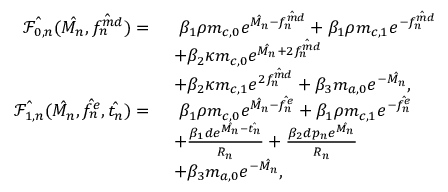<formula> <loc_0><loc_0><loc_500><loc_500>\begin{array} { r l } { \hat { \mathcal { F } _ { 0 , n } } ( \hat { M _ { n } } , \hat { f _ { n } ^ { m d } } ) = \ } & { \ \beta _ { 1 } \rho m _ { c , 0 } e ^ { \hat { M _ { n } } - \hat { f _ { n } ^ { m d } } } + \beta _ { 1 } \rho m _ { c , 1 } e ^ { - \hat { f _ { n } ^ { m d } } } } \\ & { + \beta _ { 2 } \kappa m _ { c , 0 } e ^ { \hat { M _ { n } } + 2 \hat { f _ { n } ^ { m d } } } } \\ & { + \beta _ { 2 } \kappa m _ { c , 1 } e ^ { 2 \hat { f _ { n } ^ { m d } } } + \beta _ { 3 } m _ { a , 0 } e ^ { - \hat { M _ { n } } } , } \\ { \hat { \mathcal { F } _ { 1 , n } } ( \hat { M _ { n } } , \hat { f _ { n } ^ { e } } , \hat { t _ { n } } ) = \ } & { \ \beta _ { 1 } \rho m _ { c , 0 } e ^ { \hat { M _ { n } } - \hat { f _ { n } ^ { e } } } + \beta _ { 1 } \rho m _ { c , 1 } e ^ { - \hat { f _ { n } ^ { e } } } } \\ & { + \frac { \beta _ { 1 } d e ^ { \hat { M _ { n } } - \hat { t _ { n } } } } { R _ { n } } + \frac { \beta _ { 2 } d p _ { n } e ^ { \hat { M _ { n } } } } { R _ { n } } } \\ & { + \beta _ { 3 } m _ { a , 0 } e ^ { - \hat { M _ { n } } } , } \end{array}</formula> 